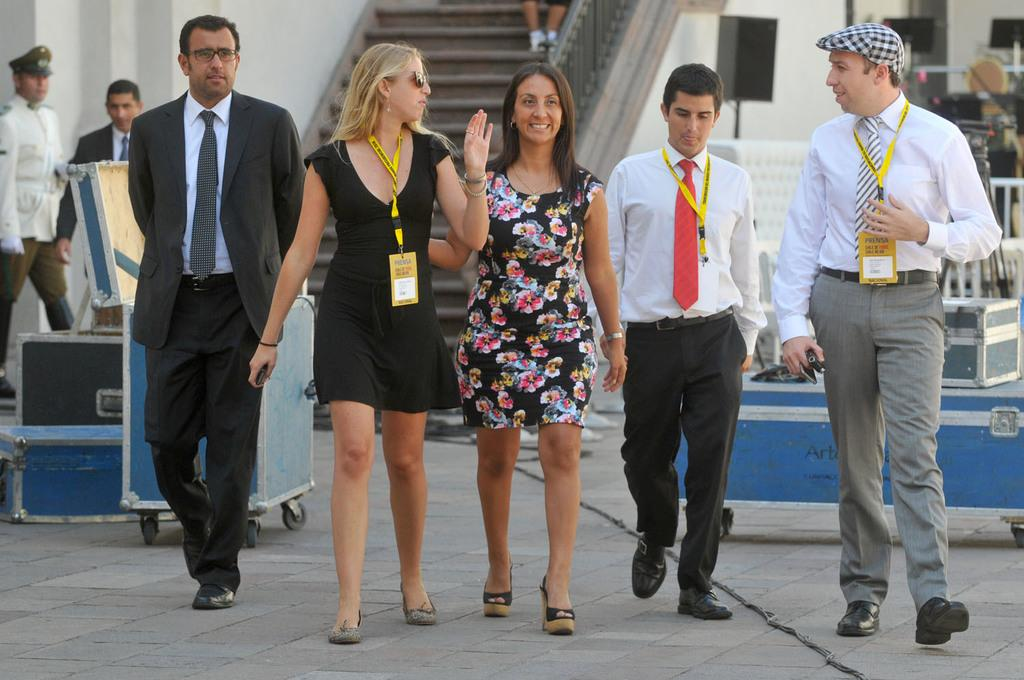What are the people in the image doing? The people in the image are walking. How do the people appear to be feeling in the image? The people have smiles on their faces, indicating they are happy or content. What might suggest that the people in the image are traveling? The presence of suitcases in the image suggests that the people are traveling. How many people are standing in the image? A: Two people are standing in the image. What can be seen in the background of the image? There is a staircase visible in the background of the image. What type of riddle can be seen written on the wall in the image? There is no riddle written on the wall in the image; it only shows people walking, smiling, and carrying suitcases. What is the name of the town where the people in the image are walking? The image does not provide information about the town or location where the people are walking. 